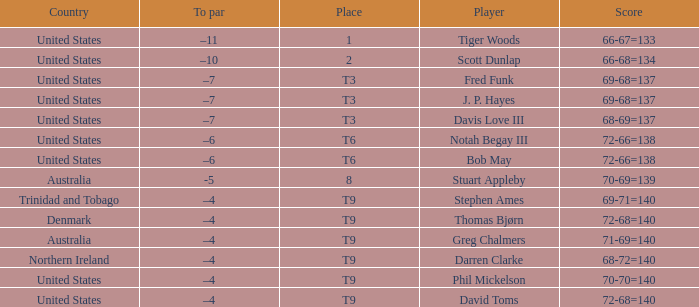What is the To par value that goes with a Score of 70-69=139? -5.0. 